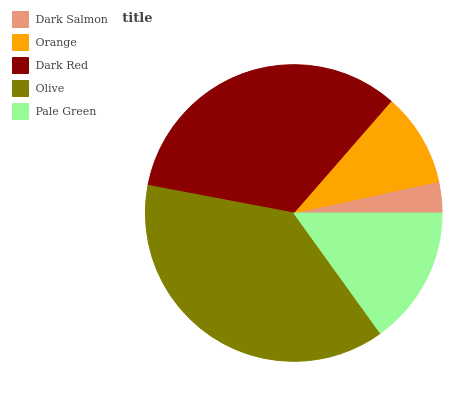Is Dark Salmon the minimum?
Answer yes or no. Yes. Is Olive the maximum?
Answer yes or no. Yes. Is Orange the minimum?
Answer yes or no. No. Is Orange the maximum?
Answer yes or no. No. Is Orange greater than Dark Salmon?
Answer yes or no. Yes. Is Dark Salmon less than Orange?
Answer yes or no. Yes. Is Dark Salmon greater than Orange?
Answer yes or no. No. Is Orange less than Dark Salmon?
Answer yes or no. No. Is Pale Green the high median?
Answer yes or no. Yes. Is Pale Green the low median?
Answer yes or no. Yes. Is Orange the high median?
Answer yes or no. No. Is Olive the low median?
Answer yes or no. No. 